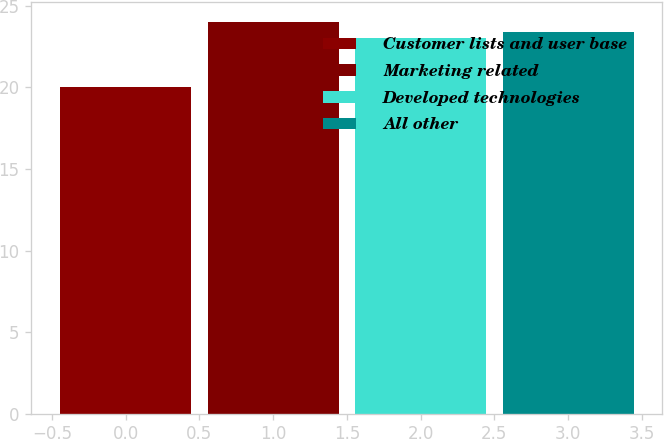Convert chart to OTSL. <chart><loc_0><loc_0><loc_500><loc_500><bar_chart><fcel>Customer lists and user base<fcel>Marketing related<fcel>Developed technologies<fcel>All other<nl><fcel>20<fcel>24<fcel>23<fcel>23.4<nl></chart> 